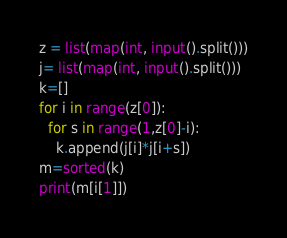<code> <loc_0><loc_0><loc_500><loc_500><_Python_>z = list(map(int, input().split()))
j= list(map(int, input().split()))
k=[]
for i in range(z[0]):
  for s in range(1,z[0]-i):
    k.append(j[i]*j[i+s])
m=sorted(k)
print(m[i[1]])</code> 